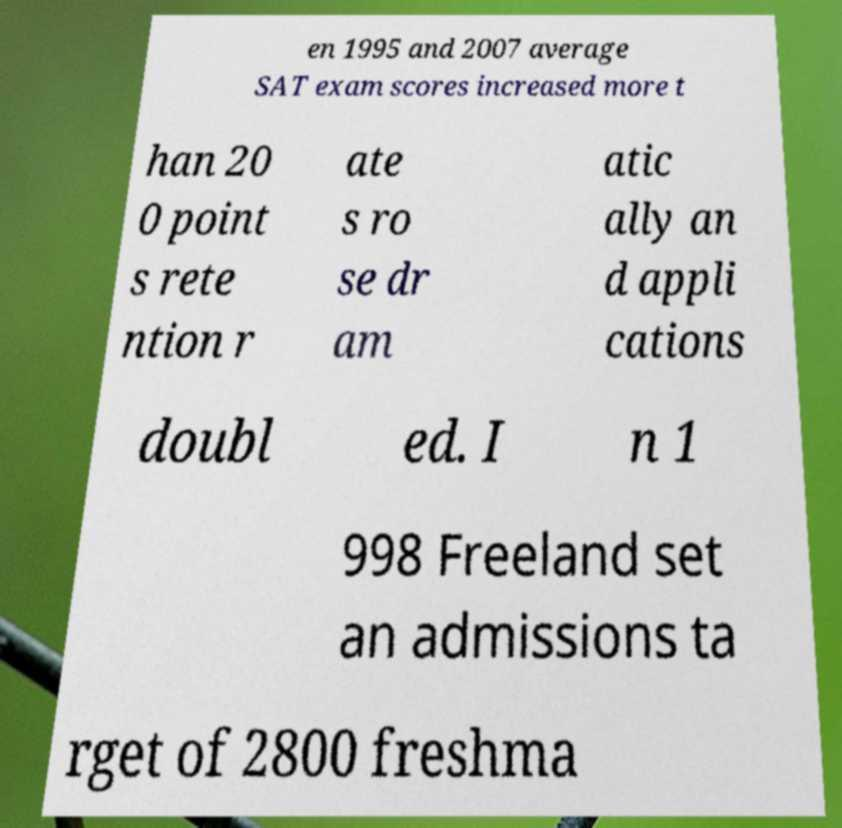Could you assist in decoding the text presented in this image and type it out clearly? en 1995 and 2007 average SAT exam scores increased more t han 20 0 point s rete ntion r ate s ro se dr am atic ally an d appli cations doubl ed. I n 1 998 Freeland set an admissions ta rget of 2800 freshma 